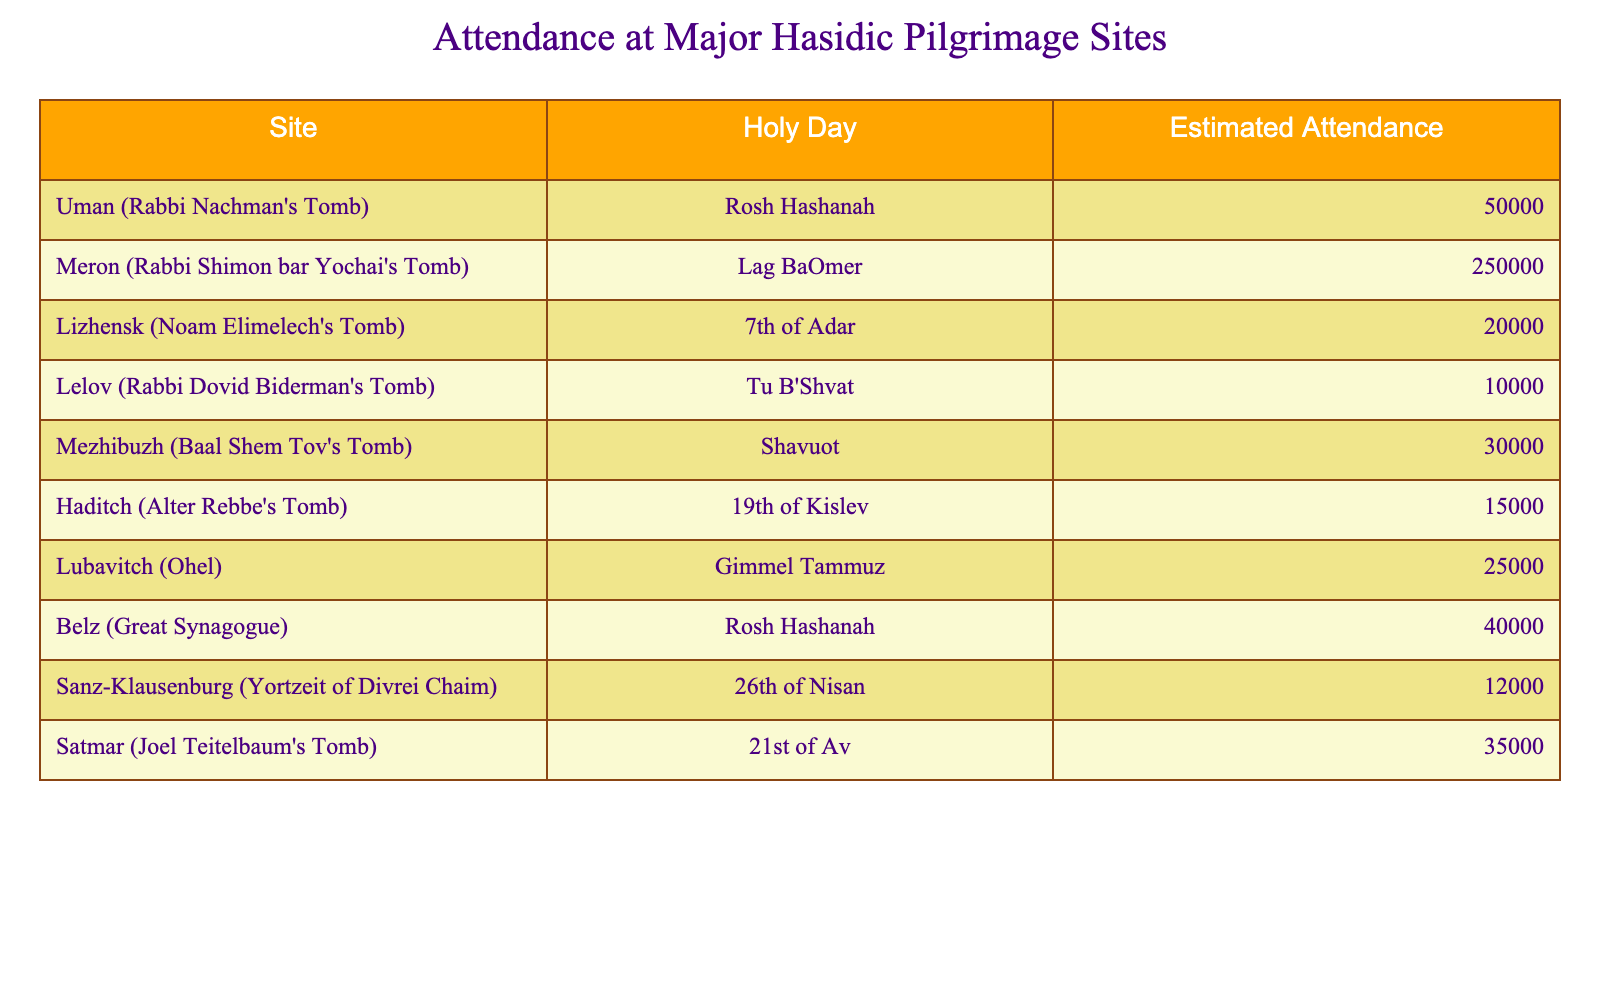What is the estimated attendance at Uman on Rosh Hashanah? The table shows that the estimated attendance at Uman (Rabbi Nachman's Tomb) during Rosh Hashanah is listed as 50,000.
Answer: 50,000 Which site has the highest estimated attendance and what is that attendance? By comparing the estimated attendance values in the table, Meron (Rabbi Shimon bar Yochai's Tomb) has the highest estimated attendance at 250,000 during Lag BaOmer.
Answer: 250,000 What is the total estimated attendance at the sites listed for Rosh Hashanah? The total estimated attendance for Rosh Hashanah can be calculated by adding the attendance at Uman (50,000) and Belz (40,000). Thus, 50,000 + 40,000 = 90,000.
Answer: 90,000 Is the estimated attendance at Lizhensk greater than that at Lelov? The attendance at Lizhensk is 20,000 and at Lelov it is 10,000. Since 20,000 is greater than 10,000, the statement is true.
Answer: Yes What is the average estimated attendance across all the sites listed in the table? To find the average, first sum all the estimated attendance values: 50,000 + 250,000 + 20,000 + 10,000 + 30,000 + 15,000 + 25,000 + 40,000 + 12,000 + 35,000 = 512,000. There are 10 sites, so the average is 512,000 / 10 = 51,200.
Answer: 51,200 Which holy day has the lowest estimated attendance and what is that attendance? By analyzing the attendance values, Lelov (10000) during Tu B'Shvat has the lowest estimated attendance.
Answer: 10,000 How many sites listed have an estimated attendance of more than 30,000? From the table, the sites with attendance greater than 30,000 are Uman (50,000), Meron (250,000), Belz (40,000), Satmar (35,000), and Mezhibuzh (30,000). This gives us a total of 5 sites.
Answer: 5 What is the difference in estimated attendance between the site with the highest attendance and the site with the lowest attendance? The highest attendance is at Meron (250,000) and the lowest is at Lelov (10,000). The difference is 250,000 - 10,000 = 240,000.
Answer: 240,000 Are there any sites where the attendance is between 10,000 and 30,000? Yes, the sites with attendance between 10,000 and 30,000 are Haditch (15,000) and Lelov (10,000).
Answer: Yes If you combine the estimated attendance for Lubavitch and Haditch, what would the total be? The estimated attendance for Lubavitch is 25,000 and for Haditch it is 15,000. Adding these gives 25,000 + 15,000 = 40,000.
Answer: 40,000 